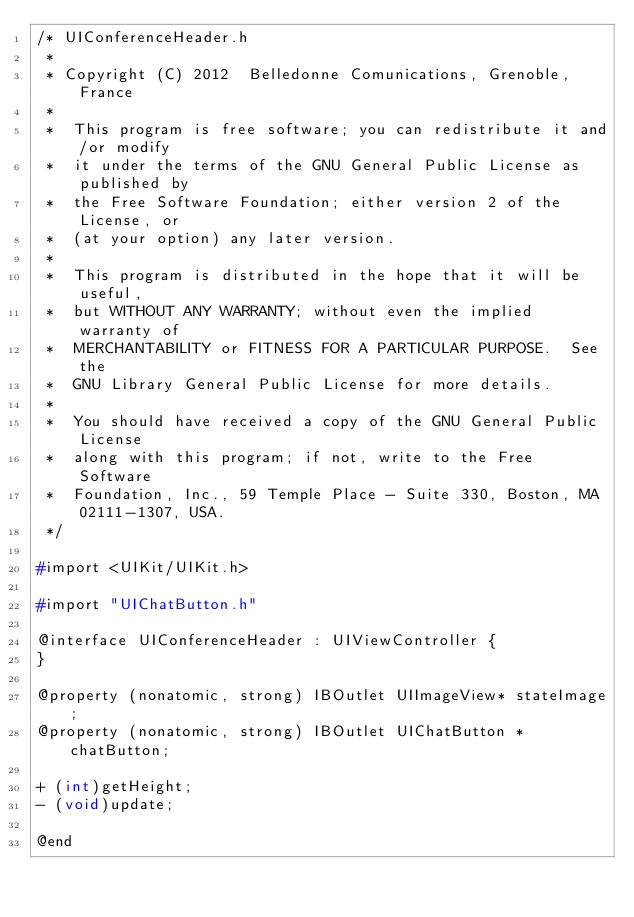Convert code to text. <code><loc_0><loc_0><loc_500><loc_500><_C_>/* UIConferenceHeader.h
 *
 * Copyright (C) 2012  Belledonne Comunications, Grenoble, France
 *
 *  This program is free software; you can redistribute it and/or modify
 *  it under the terms of the GNU General Public License as published by
 *  the Free Software Foundation; either version 2 of the License, or   
 *  (at your option) any later version.                                 
 *                                                                      
 *  This program is distributed in the hope that it will be useful,     
 *  but WITHOUT ANY WARRANTY; without even the implied warranty of      
 *  MERCHANTABILITY or FITNESS FOR A PARTICULAR PURPOSE.  See the       
 *  GNU Library General Public License for more details.                
 *                                                                      
 *  You should have received a copy of the GNU General Public License   
 *  along with this program; if not, write to the Free Software         
 *  Foundation, Inc., 59 Temple Place - Suite 330, Boston, MA 02111-1307, USA.
 */ 

#import <UIKit/UIKit.h>

#import "UIChatButton.h"

@interface UIConferenceHeader : UIViewController {
}

@property (nonatomic, strong) IBOutlet UIImageView* stateImage;
@property (nonatomic, strong) IBOutlet UIChatButton *chatButton;

+ (int)getHeight;
- (void)update;

@end
</code> 